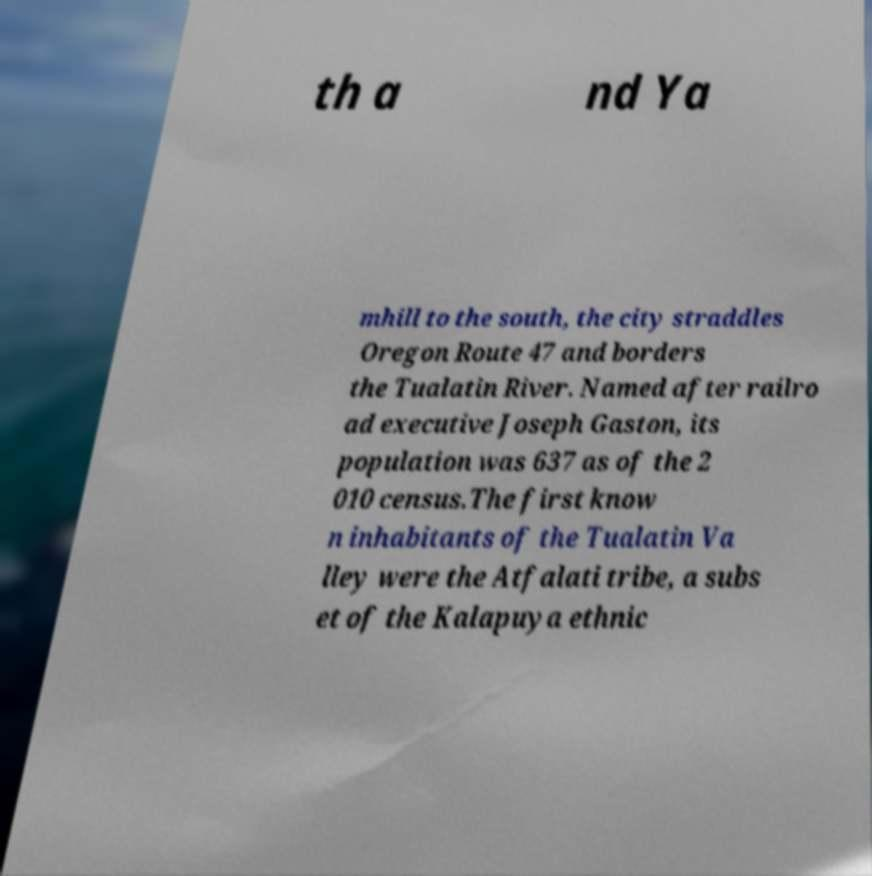Could you assist in decoding the text presented in this image and type it out clearly? th a nd Ya mhill to the south, the city straddles Oregon Route 47 and borders the Tualatin River. Named after railro ad executive Joseph Gaston, its population was 637 as of the 2 010 census.The first know n inhabitants of the Tualatin Va lley were the Atfalati tribe, a subs et of the Kalapuya ethnic 